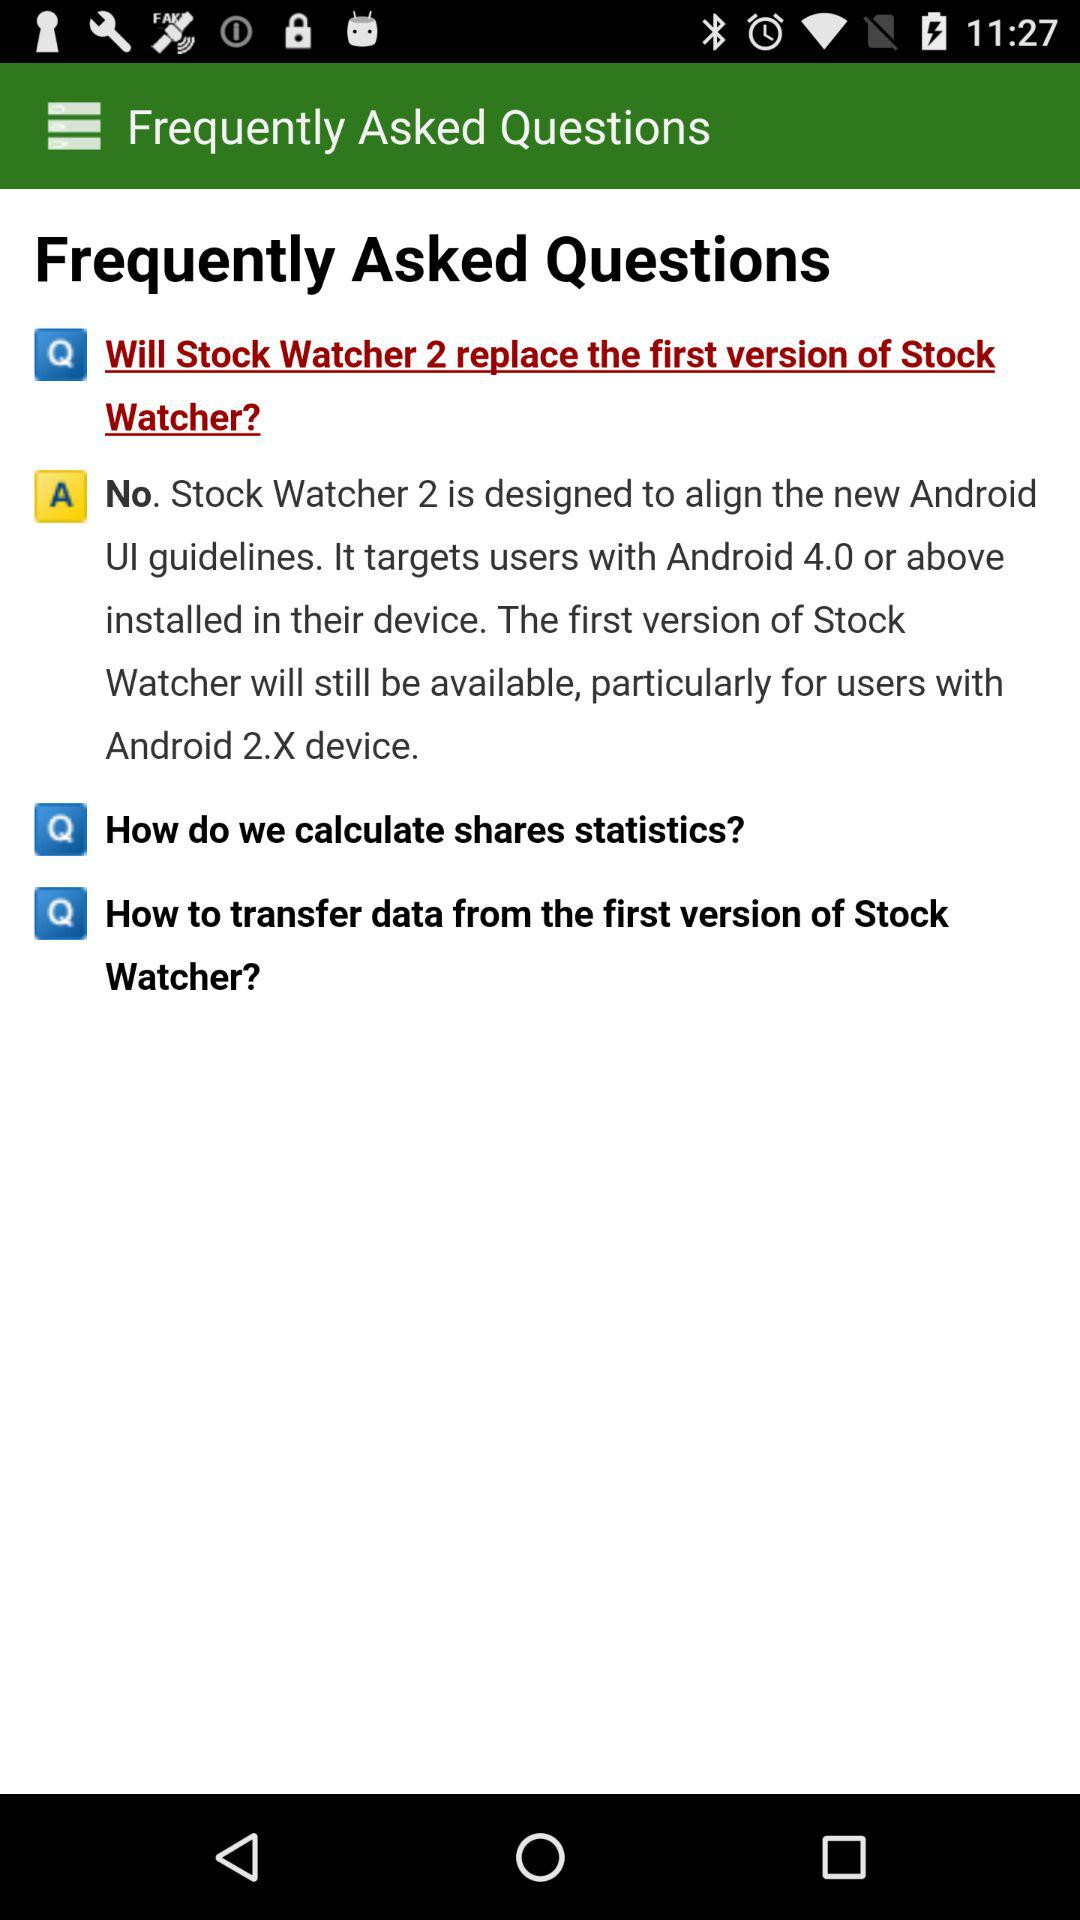How many FAQs are there in total?
Answer the question using a single word or phrase. 3 